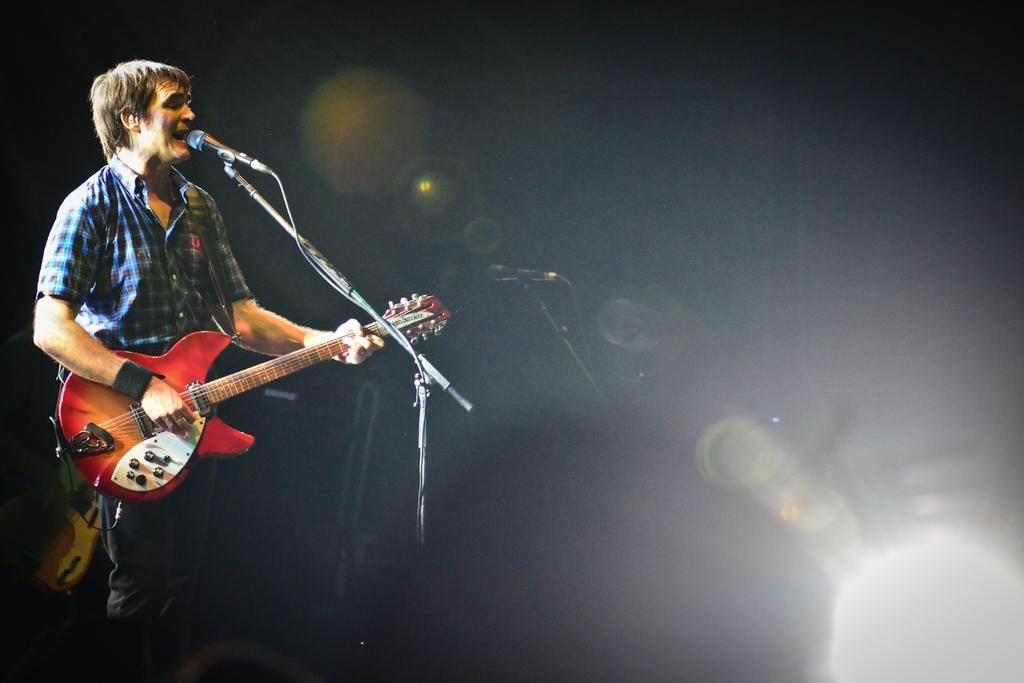What are the children doing in the image? The children are playing with a ball in a playground. What type of equipment is available in the playground? The playground has swings and slides. What type of flesh can be seen on the swings in the image? There is no flesh present in the image; it features children playing in a playground with swings and slides. What type of destruction is depicted in the image? There is no destruction depicted in the image; it features a playground with children playing. 